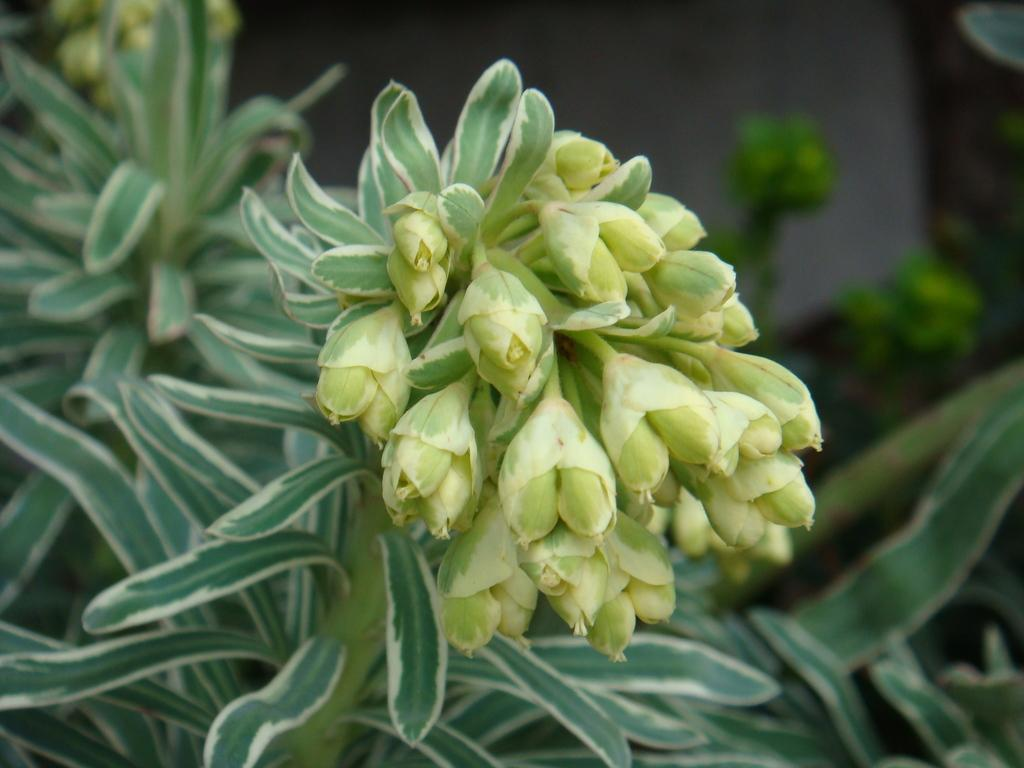What type of plant parts can be seen in the image? There are buds, leaves, and stems in the image. Can you describe the appearance of the buds in the image? The buds in the image are small and appear to be in the process of blooming. What is the background of the image like? The background of the image is blurry. What type of birds can be seen flying in the image? There are no birds visible in the image; it only features plant parts and a blurry background. What discovery was made by the ear in the image? There is no ear or discovery present in the image. 